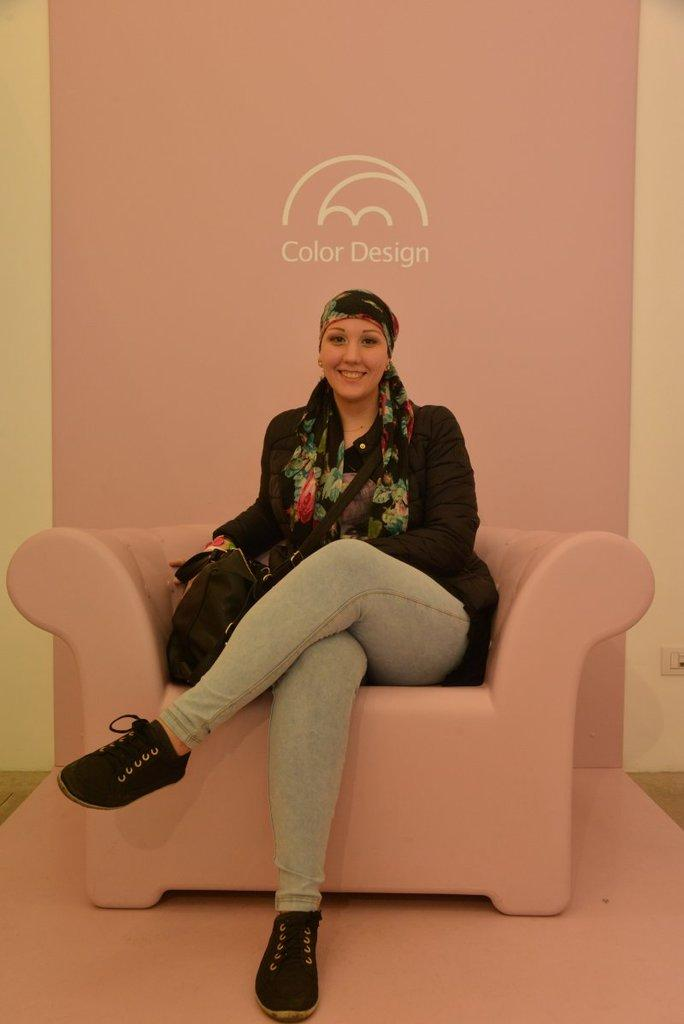Who is the main subject in the image? There is a woman in the image. What is the woman doing in the image? The woman is sitting on a sofa. What is the woman's facial expression in the image? The woman is smiling in the image. What is the woman wearing in the image? The woman is wearing a scarf in the image. What other object can be seen in the image? There is a bag in the image. What type of work does the writer do in the image? There is no writer present in the image, and therefore no work can be observed. 